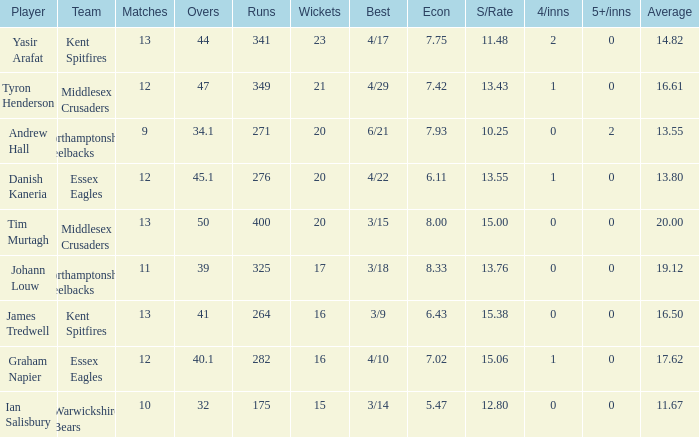Identify the four most significant innings. 2.0. 